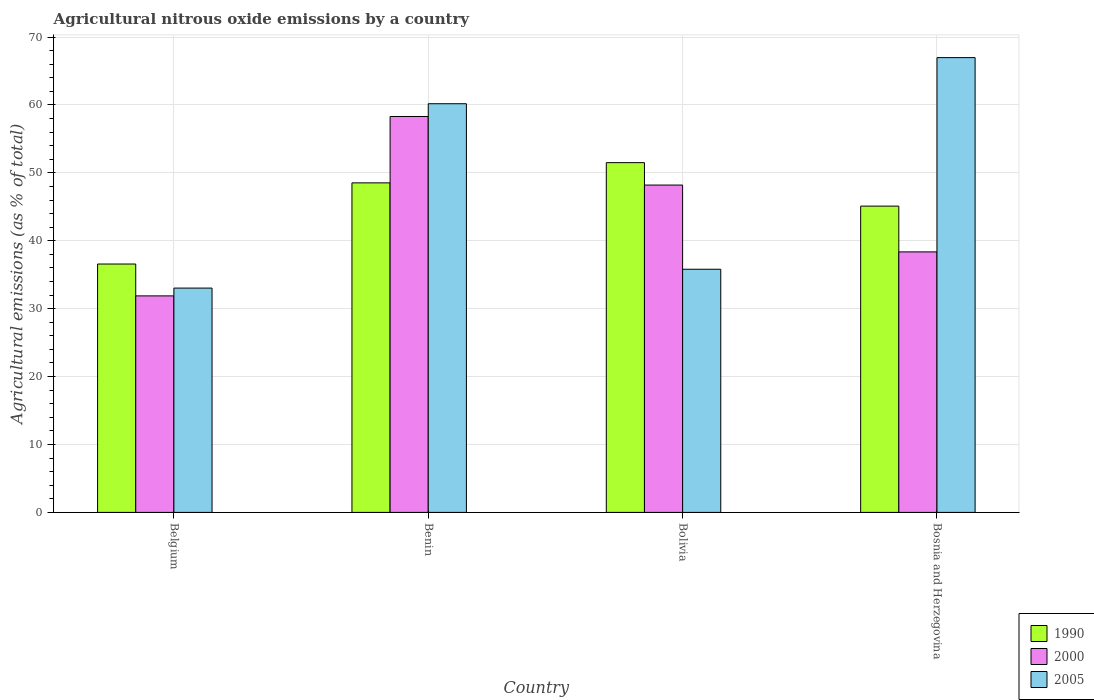How many groups of bars are there?
Your answer should be very brief. 4. Are the number of bars per tick equal to the number of legend labels?
Your response must be concise. Yes. How many bars are there on the 3rd tick from the left?
Keep it short and to the point. 3. What is the label of the 2nd group of bars from the left?
Provide a short and direct response. Benin. What is the amount of agricultural nitrous oxide emitted in 1990 in Benin?
Keep it short and to the point. 48.52. Across all countries, what is the maximum amount of agricultural nitrous oxide emitted in 2005?
Provide a succinct answer. 66.97. Across all countries, what is the minimum amount of agricultural nitrous oxide emitted in 2000?
Make the answer very short. 31.88. In which country was the amount of agricultural nitrous oxide emitted in 2005 maximum?
Offer a terse response. Bosnia and Herzegovina. What is the total amount of agricultural nitrous oxide emitted in 2000 in the graph?
Provide a succinct answer. 176.74. What is the difference between the amount of agricultural nitrous oxide emitted in 2005 in Belgium and that in Bosnia and Herzegovina?
Provide a short and direct response. -33.94. What is the difference between the amount of agricultural nitrous oxide emitted in 1990 in Bosnia and Herzegovina and the amount of agricultural nitrous oxide emitted in 2005 in Benin?
Give a very brief answer. -15.08. What is the average amount of agricultural nitrous oxide emitted in 1990 per country?
Offer a very short reply. 45.42. What is the difference between the amount of agricultural nitrous oxide emitted of/in 2005 and amount of agricultural nitrous oxide emitted of/in 1990 in Benin?
Your answer should be compact. 11.65. What is the ratio of the amount of agricultural nitrous oxide emitted in 2000 in Benin to that in Bosnia and Herzegovina?
Your response must be concise. 1.52. Is the amount of agricultural nitrous oxide emitted in 1990 in Benin less than that in Bosnia and Herzegovina?
Offer a very short reply. No. Is the difference between the amount of agricultural nitrous oxide emitted in 2005 in Benin and Bosnia and Herzegovina greater than the difference between the amount of agricultural nitrous oxide emitted in 1990 in Benin and Bosnia and Herzegovina?
Your answer should be very brief. No. What is the difference between the highest and the second highest amount of agricultural nitrous oxide emitted in 2005?
Your answer should be compact. 31.16. What is the difference between the highest and the lowest amount of agricultural nitrous oxide emitted in 1990?
Keep it short and to the point. 14.93. In how many countries, is the amount of agricultural nitrous oxide emitted in 1990 greater than the average amount of agricultural nitrous oxide emitted in 1990 taken over all countries?
Offer a very short reply. 2. What does the 1st bar from the right in Belgium represents?
Keep it short and to the point. 2005. How many bars are there?
Offer a very short reply. 12. Are all the bars in the graph horizontal?
Provide a succinct answer. No. What is the difference between two consecutive major ticks on the Y-axis?
Keep it short and to the point. 10. Are the values on the major ticks of Y-axis written in scientific E-notation?
Offer a very short reply. No. What is the title of the graph?
Provide a short and direct response. Agricultural nitrous oxide emissions by a country. Does "2003" appear as one of the legend labels in the graph?
Your response must be concise. No. What is the label or title of the Y-axis?
Your answer should be very brief. Agricultural emissions (as % of total). What is the Agricultural emissions (as % of total) of 1990 in Belgium?
Provide a succinct answer. 36.57. What is the Agricultural emissions (as % of total) of 2000 in Belgium?
Keep it short and to the point. 31.88. What is the Agricultural emissions (as % of total) of 2005 in Belgium?
Your response must be concise. 33.03. What is the Agricultural emissions (as % of total) of 1990 in Benin?
Keep it short and to the point. 48.52. What is the Agricultural emissions (as % of total) of 2000 in Benin?
Give a very brief answer. 58.3. What is the Agricultural emissions (as % of total) of 2005 in Benin?
Give a very brief answer. 60.18. What is the Agricultural emissions (as % of total) in 1990 in Bolivia?
Your answer should be compact. 51.5. What is the Agricultural emissions (as % of total) of 2000 in Bolivia?
Offer a terse response. 48.2. What is the Agricultural emissions (as % of total) of 2005 in Bolivia?
Give a very brief answer. 35.8. What is the Agricultural emissions (as % of total) in 1990 in Bosnia and Herzegovina?
Your answer should be very brief. 45.1. What is the Agricultural emissions (as % of total) of 2000 in Bosnia and Herzegovina?
Offer a terse response. 38.36. What is the Agricultural emissions (as % of total) in 2005 in Bosnia and Herzegovina?
Offer a terse response. 66.97. Across all countries, what is the maximum Agricultural emissions (as % of total) in 1990?
Your answer should be very brief. 51.5. Across all countries, what is the maximum Agricultural emissions (as % of total) of 2000?
Your response must be concise. 58.3. Across all countries, what is the maximum Agricultural emissions (as % of total) of 2005?
Ensure brevity in your answer.  66.97. Across all countries, what is the minimum Agricultural emissions (as % of total) of 1990?
Offer a terse response. 36.57. Across all countries, what is the minimum Agricultural emissions (as % of total) in 2000?
Keep it short and to the point. 31.88. Across all countries, what is the minimum Agricultural emissions (as % of total) of 2005?
Your answer should be very brief. 33.03. What is the total Agricultural emissions (as % of total) in 1990 in the graph?
Your response must be concise. 181.7. What is the total Agricultural emissions (as % of total) in 2000 in the graph?
Your answer should be compact. 176.74. What is the total Agricultural emissions (as % of total) in 2005 in the graph?
Your answer should be compact. 195.98. What is the difference between the Agricultural emissions (as % of total) in 1990 in Belgium and that in Benin?
Ensure brevity in your answer.  -11.95. What is the difference between the Agricultural emissions (as % of total) in 2000 in Belgium and that in Benin?
Provide a succinct answer. -26.42. What is the difference between the Agricultural emissions (as % of total) of 2005 in Belgium and that in Benin?
Keep it short and to the point. -27.15. What is the difference between the Agricultural emissions (as % of total) in 1990 in Belgium and that in Bolivia?
Offer a terse response. -14.93. What is the difference between the Agricultural emissions (as % of total) in 2000 in Belgium and that in Bolivia?
Make the answer very short. -16.32. What is the difference between the Agricultural emissions (as % of total) of 2005 in Belgium and that in Bolivia?
Keep it short and to the point. -2.78. What is the difference between the Agricultural emissions (as % of total) of 1990 in Belgium and that in Bosnia and Herzegovina?
Offer a very short reply. -8.53. What is the difference between the Agricultural emissions (as % of total) of 2000 in Belgium and that in Bosnia and Herzegovina?
Your response must be concise. -6.48. What is the difference between the Agricultural emissions (as % of total) in 2005 in Belgium and that in Bosnia and Herzegovina?
Keep it short and to the point. -33.94. What is the difference between the Agricultural emissions (as % of total) of 1990 in Benin and that in Bolivia?
Make the answer very short. -2.98. What is the difference between the Agricultural emissions (as % of total) of 2000 in Benin and that in Bolivia?
Give a very brief answer. 10.1. What is the difference between the Agricultural emissions (as % of total) in 2005 in Benin and that in Bolivia?
Provide a short and direct response. 24.37. What is the difference between the Agricultural emissions (as % of total) of 1990 in Benin and that in Bosnia and Herzegovina?
Your answer should be compact. 3.42. What is the difference between the Agricultural emissions (as % of total) of 2000 in Benin and that in Bosnia and Herzegovina?
Offer a terse response. 19.94. What is the difference between the Agricultural emissions (as % of total) in 2005 in Benin and that in Bosnia and Herzegovina?
Your answer should be compact. -6.79. What is the difference between the Agricultural emissions (as % of total) of 1990 in Bolivia and that in Bosnia and Herzegovina?
Your answer should be very brief. 6.4. What is the difference between the Agricultural emissions (as % of total) in 2000 in Bolivia and that in Bosnia and Herzegovina?
Provide a succinct answer. 9.84. What is the difference between the Agricultural emissions (as % of total) of 2005 in Bolivia and that in Bosnia and Herzegovina?
Make the answer very short. -31.16. What is the difference between the Agricultural emissions (as % of total) in 1990 in Belgium and the Agricultural emissions (as % of total) in 2000 in Benin?
Your response must be concise. -21.72. What is the difference between the Agricultural emissions (as % of total) in 1990 in Belgium and the Agricultural emissions (as % of total) in 2005 in Benin?
Your response must be concise. -23.6. What is the difference between the Agricultural emissions (as % of total) in 2000 in Belgium and the Agricultural emissions (as % of total) in 2005 in Benin?
Keep it short and to the point. -28.3. What is the difference between the Agricultural emissions (as % of total) in 1990 in Belgium and the Agricultural emissions (as % of total) in 2000 in Bolivia?
Give a very brief answer. -11.63. What is the difference between the Agricultural emissions (as % of total) in 1990 in Belgium and the Agricultural emissions (as % of total) in 2005 in Bolivia?
Ensure brevity in your answer.  0.77. What is the difference between the Agricultural emissions (as % of total) of 2000 in Belgium and the Agricultural emissions (as % of total) of 2005 in Bolivia?
Your answer should be very brief. -3.92. What is the difference between the Agricultural emissions (as % of total) in 1990 in Belgium and the Agricultural emissions (as % of total) in 2000 in Bosnia and Herzegovina?
Your answer should be very brief. -1.78. What is the difference between the Agricultural emissions (as % of total) in 1990 in Belgium and the Agricultural emissions (as % of total) in 2005 in Bosnia and Herzegovina?
Your answer should be compact. -30.39. What is the difference between the Agricultural emissions (as % of total) of 2000 in Belgium and the Agricultural emissions (as % of total) of 2005 in Bosnia and Herzegovina?
Offer a terse response. -35.09. What is the difference between the Agricultural emissions (as % of total) in 1990 in Benin and the Agricultural emissions (as % of total) in 2000 in Bolivia?
Make the answer very short. 0.32. What is the difference between the Agricultural emissions (as % of total) of 1990 in Benin and the Agricultural emissions (as % of total) of 2005 in Bolivia?
Make the answer very short. 12.72. What is the difference between the Agricultural emissions (as % of total) of 2000 in Benin and the Agricultural emissions (as % of total) of 2005 in Bolivia?
Give a very brief answer. 22.49. What is the difference between the Agricultural emissions (as % of total) in 1990 in Benin and the Agricultural emissions (as % of total) in 2000 in Bosnia and Herzegovina?
Your answer should be compact. 10.16. What is the difference between the Agricultural emissions (as % of total) in 1990 in Benin and the Agricultural emissions (as % of total) in 2005 in Bosnia and Herzegovina?
Provide a short and direct response. -18.44. What is the difference between the Agricultural emissions (as % of total) of 2000 in Benin and the Agricultural emissions (as % of total) of 2005 in Bosnia and Herzegovina?
Provide a short and direct response. -8.67. What is the difference between the Agricultural emissions (as % of total) of 1990 in Bolivia and the Agricultural emissions (as % of total) of 2000 in Bosnia and Herzegovina?
Provide a short and direct response. 13.14. What is the difference between the Agricultural emissions (as % of total) of 1990 in Bolivia and the Agricultural emissions (as % of total) of 2005 in Bosnia and Herzegovina?
Make the answer very short. -15.47. What is the difference between the Agricultural emissions (as % of total) of 2000 in Bolivia and the Agricultural emissions (as % of total) of 2005 in Bosnia and Herzegovina?
Give a very brief answer. -18.77. What is the average Agricultural emissions (as % of total) in 1990 per country?
Ensure brevity in your answer.  45.42. What is the average Agricultural emissions (as % of total) of 2000 per country?
Your answer should be compact. 44.18. What is the average Agricultural emissions (as % of total) in 2005 per country?
Make the answer very short. 48.99. What is the difference between the Agricultural emissions (as % of total) of 1990 and Agricultural emissions (as % of total) of 2000 in Belgium?
Provide a succinct answer. 4.69. What is the difference between the Agricultural emissions (as % of total) in 1990 and Agricultural emissions (as % of total) in 2005 in Belgium?
Provide a short and direct response. 3.54. What is the difference between the Agricultural emissions (as % of total) of 2000 and Agricultural emissions (as % of total) of 2005 in Belgium?
Keep it short and to the point. -1.15. What is the difference between the Agricultural emissions (as % of total) of 1990 and Agricultural emissions (as % of total) of 2000 in Benin?
Offer a very short reply. -9.77. What is the difference between the Agricultural emissions (as % of total) of 1990 and Agricultural emissions (as % of total) of 2005 in Benin?
Make the answer very short. -11.65. What is the difference between the Agricultural emissions (as % of total) of 2000 and Agricultural emissions (as % of total) of 2005 in Benin?
Give a very brief answer. -1.88. What is the difference between the Agricultural emissions (as % of total) of 1990 and Agricultural emissions (as % of total) of 2000 in Bolivia?
Give a very brief answer. 3.3. What is the difference between the Agricultural emissions (as % of total) in 1990 and Agricultural emissions (as % of total) in 2005 in Bolivia?
Your response must be concise. 15.7. What is the difference between the Agricultural emissions (as % of total) of 2000 and Agricultural emissions (as % of total) of 2005 in Bolivia?
Provide a succinct answer. 12.4. What is the difference between the Agricultural emissions (as % of total) in 1990 and Agricultural emissions (as % of total) in 2000 in Bosnia and Herzegovina?
Provide a short and direct response. 6.74. What is the difference between the Agricultural emissions (as % of total) of 1990 and Agricultural emissions (as % of total) of 2005 in Bosnia and Herzegovina?
Your response must be concise. -21.87. What is the difference between the Agricultural emissions (as % of total) of 2000 and Agricultural emissions (as % of total) of 2005 in Bosnia and Herzegovina?
Ensure brevity in your answer.  -28.61. What is the ratio of the Agricultural emissions (as % of total) of 1990 in Belgium to that in Benin?
Your answer should be compact. 0.75. What is the ratio of the Agricultural emissions (as % of total) of 2000 in Belgium to that in Benin?
Your answer should be very brief. 0.55. What is the ratio of the Agricultural emissions (as % of total) in 2005 in Belgium to that in Benin?
Offer a very short reply. 0.55. What is the ratio of the Agricultural emissions (as % of total) of 1990 in Belgium to that in Bolivia?
Your response must be concise. 0.71. What is the ratio of the Agricultural emissions (as % of total) of 2000 in Belgium to that in Bolivia?
Provide a succinct answer. 0.66. What is the ratio of the Agricultural emissions (as % of total) of 2005 in Belgium to that in Bolivia?
Offer a terse response. 0.92. What is the ratio of the Agricultural emissions (as % of total) in 1990 in Belgium to that in Bosnia and Herzegovina?
Offer a very short reply. 0.81. What is the ratio of the Agricultural emissions (as % of total) in 2000 in Belgium to that in Bosnia and Herzegovina?
Make the answer very short. 0.83. What is the ratio of the Agricultural emissions (as % of total) of 2005 in Belgium to that in Bosnia and Herzegovina?
Offer a very short reply. 0.49. What is the ratio of the Agricultural emissions (as % of total) in 1990 in Benin to that in Bolivia?
Your response must be concise. 0.94. What is the ratio of the Agricultural emissions (as % of total) of 2000 in Benin to that in Bolivia?
Offer a very short reply. 1.21. What is the ratio of the Agricultural emissions (as % of total) of 2005 in Benin to that in Bolivia?
Provide a short and direct response. 1.68. What is the ratio of the Agricultural emissions (as % of total) of 1990 in Benin to that in Bosnia and Herzegovina?
Ensure brevity in your answer.  1.08. What is the ratio of the Agricultural emissions (as % of total) of 2000 in Benin to that in Bosnia and Herzegovina?
Offer a terse response. 1.52. What is the ratio of the Agricultural emissions (as % of total) of 2005 in Benin to that in Bosnia and Herzegovina?
Provide a succinct answer. 0.9. What is the ratio of the Agricultural emissions (as % of total) of 1990 in Bolivia to that in Bosnia and Herzegovina?
Your response must be concise. 1.14. What is the ratio of the Agricultural emissions (as % of total) in 2000 in Bolivia to that in Bosnia and Herzegovina?
Give a very brief answer. 1.26. What is the ratio of the Agricultural emissions (as % of total) in 2005 in Bolivia to that in Bosnia and Herzegovina?
Make the answer very short. 0.53. What is the difference between the highest and the second highest Agricultural emissions (as % of total) of 1990?
Your answer should be compact. 2.98. What is the difference between the highest and the second highest Agricultural emissions (as % of total) of 2000?
Offer a very short reply. 10.1. What is the difference between the highest and the second highest Agricultural emissions (as % of total) in 2005?
Your answer should be very brief. 6.79. What is the difference between the highest and the lowest Agricultural emissions (as % of total) of 1990?
Offer a terse response. 14.93. What is the difference between the highest and the lowest Agricultural emissions (as % of total) of 2000?
Keep it short and to the point. 26.42. What is the difference between the highest and the lowest Agricultural emissions (as % of total) in 2005?
Keep it short and to the point. 33.94. 